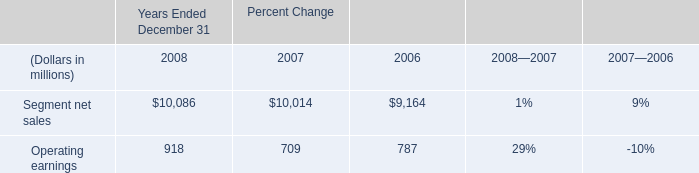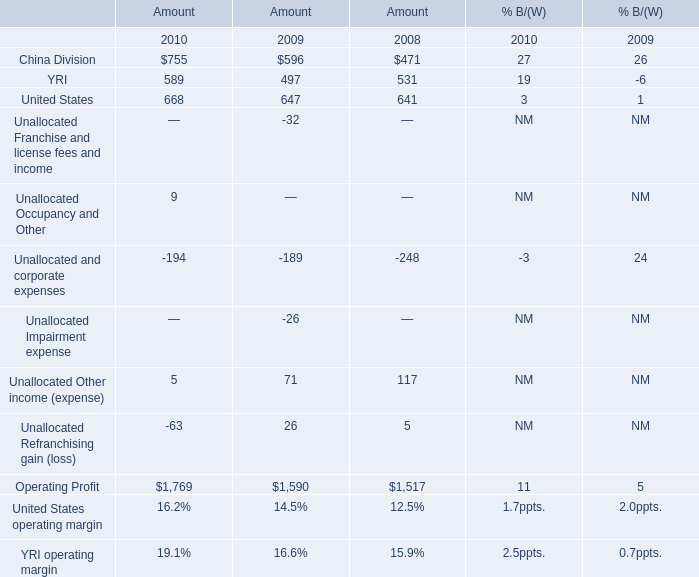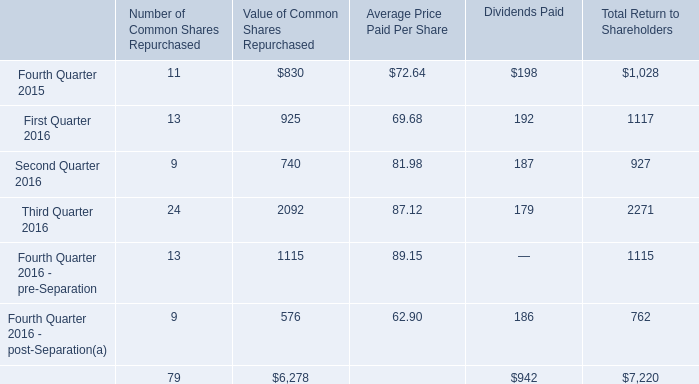what's the total amount of Operating Profit of Amount 2009, and Segment net sales of Percent Change 2006 ? 
Computations: (1590.0 + 9164.0)
Answer: 10754.0. 